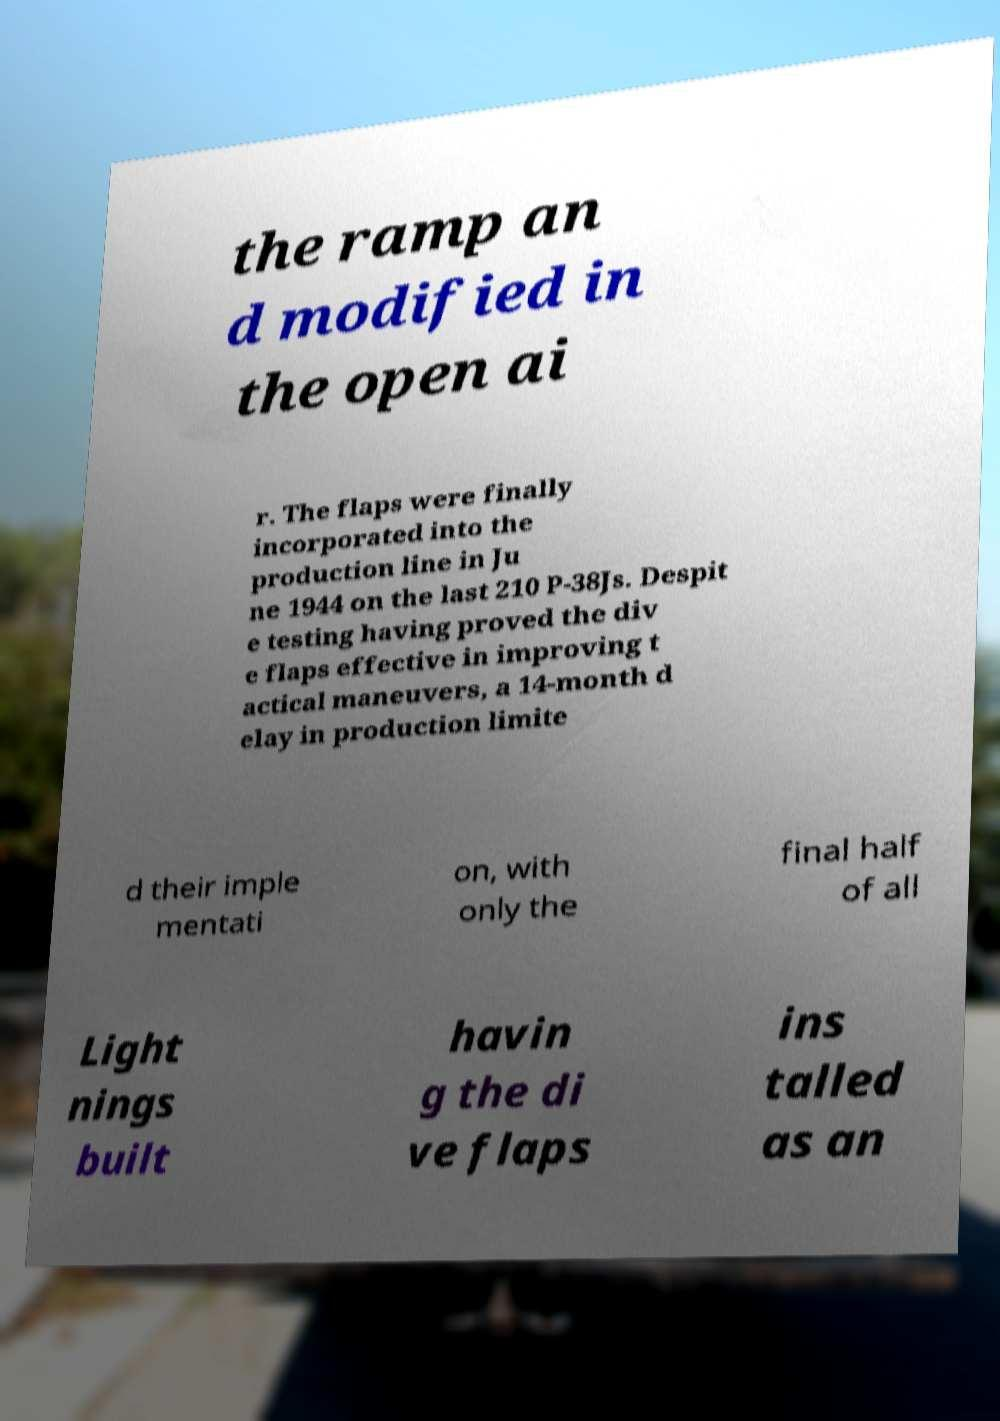There's text embedded in this image that I need extracted. Can you transcribe it verbatim? the ramp an d modified in the open ai r. The flaps were finally incorporated into the production line in Ju ne 1944 on the last 210 P-38Js. Despit e testing having proved the div e flaps effective in improving t actical maneuvers, a 14-month d elay in production limite d their imple mentati on, with only the final half of all Light nings built havin g the di ve flaps ins talled as an 